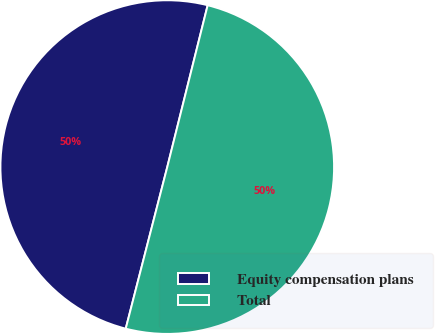Convert chart. <chart><loc_0><loc_0><loc_500><loc_500><pie_chart><fcel>Equity compensation plans<fcel>Total<nl><fcel>49.89%<fcel>50.11%<nl></chart> 